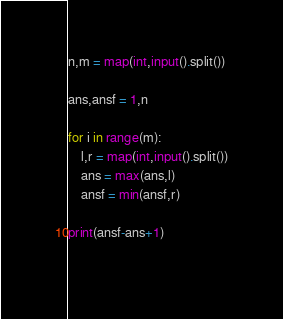Convert code to text. <code><loc_0><loc_0><loc_500><loc_500><_Python_>n,m = map(int,input().split())

ans,ansf = 1,n

for i in range(m):
    l,r = map(int,input().split())
    ans = max(ans,l)
    ansf = min(ansf,r)
    
print(ansf-ans+1)
    </code> 